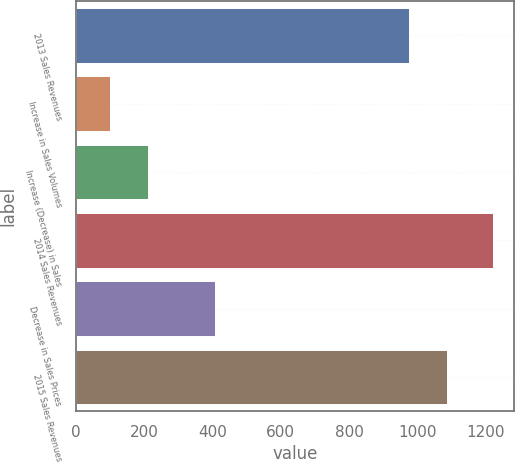Convert chart. <chart><loc_0><loc_0><loc_500><loc_500><bar_chart><fcel>2013 Sales Revenues<fcel>Increase in Sales Volumes<fcel>Increase (Decrease) in Sales<fcel>2014 Sales Revenues<fcel>Decrease in Sales Prices<fcel>2015 Sales Revenues<nl><fcel>976<fcel>99<fcel>211.4<fcel>1223<fcel>408<fcel>1088.4<nl></chart> 